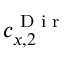<formula> <loc_0><loc_0><loc_500><loc_500>c _ { x , 2 } ^ { D i r }</formula> 